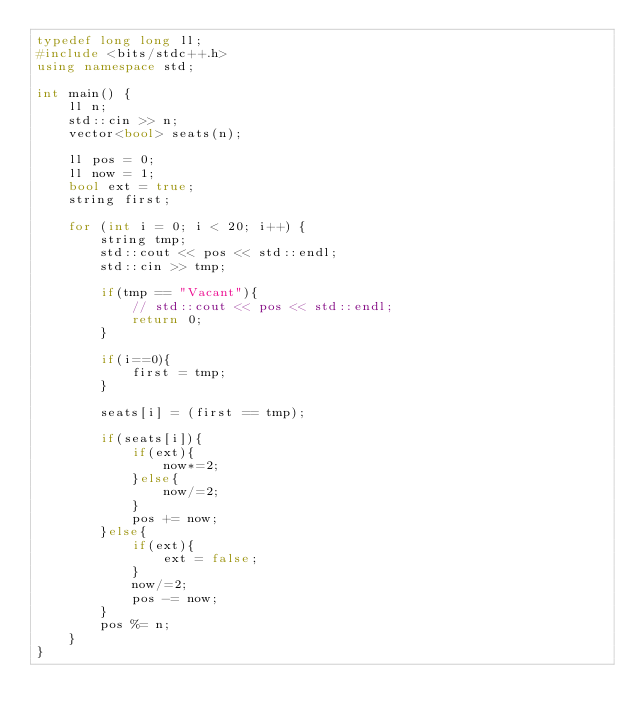Convert code to text. <code><loc_0><loc_0><loc_500><loc_500><_C++_>typedef long long ll;
#include <bits/stdc++.h>
using namespace std;

int main() {
    ll n;
    std::cin >> n;
    vector<bool> seats(n);
    
    ll pos = 0;
    ll now = 1;
    bool ext = true;
    string first;

    for (int i = 0; i < 20; i++) {
        string tmp;
        std::cout << pos << std::endl;
        std::cin >> tmp;
        
        if(tmp == "Vacant"){
            // std::cout << pos << std::endl;
            return 0;
        }
        
        if(i==0){
            first = tmp;
        }
        
        seats[i] = (first == tmp); 
        
        if(seats[i]){
            if(ext){
                now*=2;
            }else{
                now/=2;
            }
            pos += now;
        }else{
            if(ext){
                ext = false;
            }
            now/=2;
            pos -= now;
        }
        pos %= n;
    }
}
</code> 